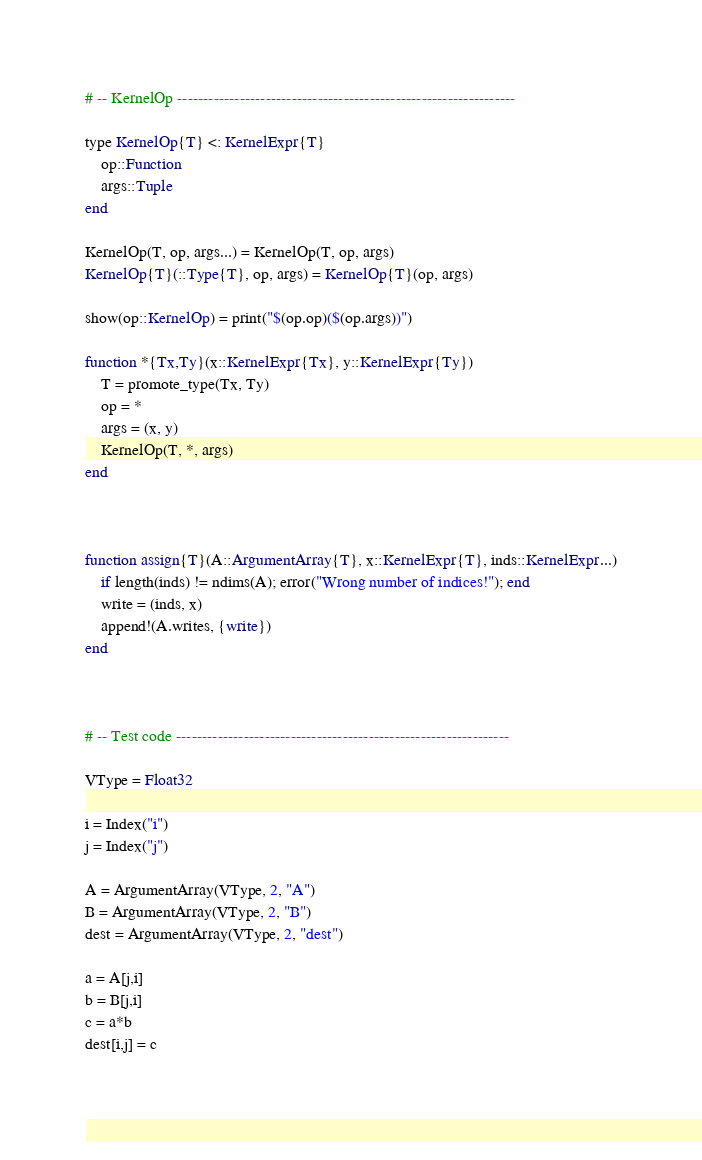Convert code to text. <code><loc_0><loc_0><loc_500><loc_500><_Julia_>
# -- KernelOp -----------------------------------------------------------------

type KernelOp{T} <: KernelExpr{T}
    op::Function
    args::Tuple
end

KernelOp(T, op, args...) = KernelOp(T, op, args)
KernelOp{T}(::Type{T}, op, args) = KernelOp{T}(op, args)

show(op::KernelOp) = print("$(op.op)($(op.args))")

function *{Tx,Ty}(x::KernelExpr{Tx}, y::KernelExpr{Ty})
    T = promote_type(Tx, Ty)
    op = *
    args = (x, y)
    KernelOp(T, *, args)
end



function assign{T}(A::ArgumentArray{T}, x::KernelExpr{T}, inds::KernelExpr...)
    if length(inds) != ndims(A); error("Wrong number of indices!"); end
    write = (inds, x)
    append!(A.writes, {write})
end



# -- Test code ----------------------------------------------------------------

VType = Float32

i = Index("i")
j = Index("j")

A = ArgumentArray(VType, 2, "A")
B = ArgumentArray(VType, 2, "B")
dest = ArgumentArray(VType, 2, "dest")

a = A[j,i]
b = B[j,i]
c = a*b
dest[i,j] = c
 
</code> 